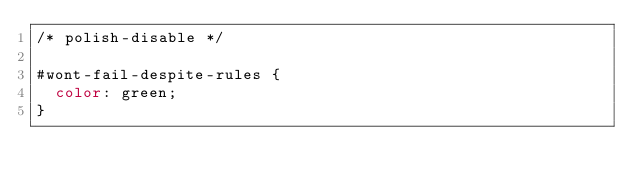Convert code to text. <code><loc_0><loc_0><loc_500><loc_500><_CSS_>/* polish-disable */

#wont-fail-despite-rules {
  color: green;
}</code> 